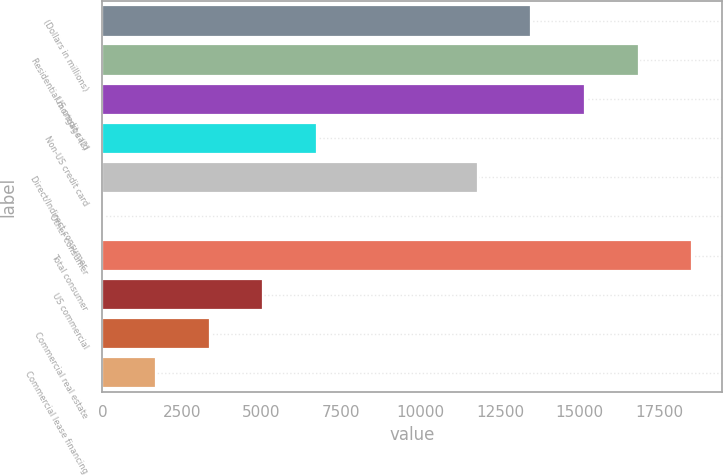<chart> <loc_0><loc_0><loc_500><loc_500><bar_chart><fcel>(Dollars in millions)<fcel>Residential mortgage (2)<fcel>US credit card<fcel>Non-US credit card<fcel>Direct/Indirect consumer<fcel>Other consumer<fcel>Total consumer<fcel>US commercial<fcel>Commercial real estate<fcel>Commercial lease financing<nl><fcel>13488.6<fcel>16860<fcel>15174.3<fcel>6745.8<fcel>11802.9<fcel>3<fcel>18545.7<fcel>5060.1<fcel>3374.4<fcel>1688.7<nl></chart> 